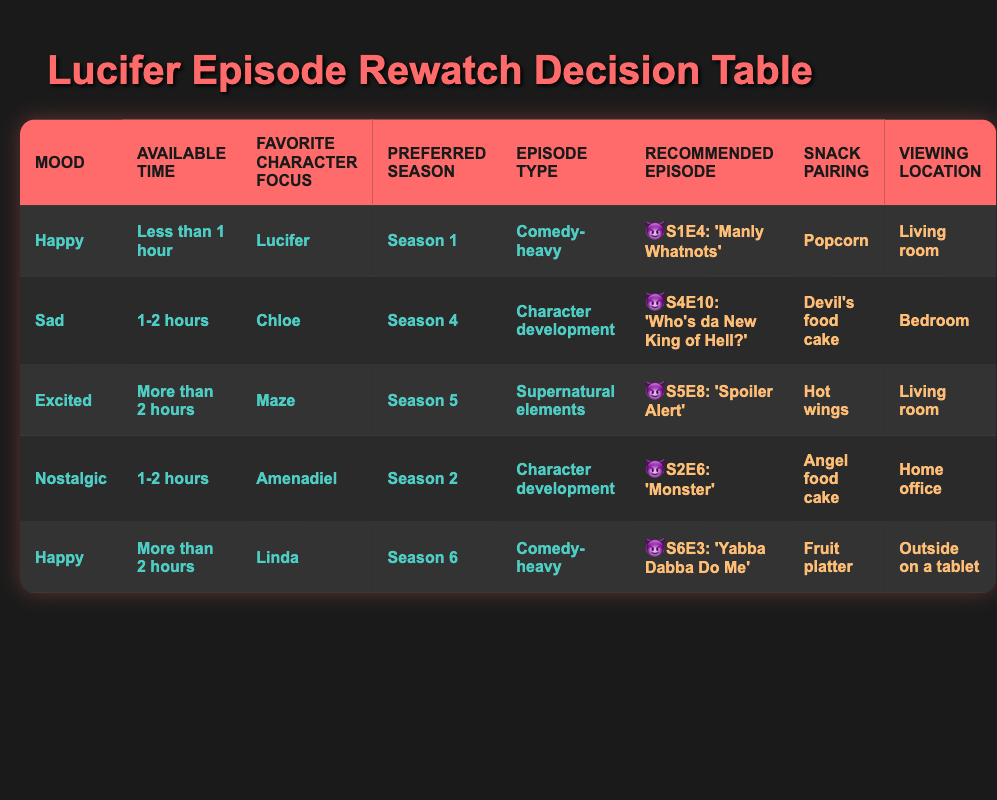What episode is recommended if I'm feeling nostalgic? According to the table, the recommended episode for a nostalgic mood is found in the row where the mood is "Nostalgic." That episode is "S2E6: 'Monster'."
Answer: S2E6: 'Monster' What snack should I pair with watching "S5E8: 'Spoiler Alert'"? In the row that lists "S5E8: 'Spoiler Alert'", the snack pairing is listed as "Hot wings."
Answer: Hot wings Is there a recommended episode for a happy mood with less than 1 hour of available time? Yes, when the mood is "Happy" and available time is "Less than 1 hour," the table suggests the episode "S1E4: 'Manly Whatnots'."
Answer: Yes How many episodes in the table are there for character development? Looking through the table, the following episodes are categorized under "Character development": "S4E10: 'Who's da New King of Hell?'", "S2E6: 'Monster'", and "S5E8: 'Spoiler Alert'." There are 3 episodes that fit this category.
Answer: 2 Which viewing location is suggested for watching a happy episode from Season 6? The row that describes a happy mood with more than 2 hours of available time suggests "Outside on a tablet" as the viewing location for "S6E3: 'Yabba Dabba Do Me'."
Answer: Outside on a tablet If I want to rewatch a case-focused episode, what is my option? By scanning through the episodes, none of the recommended episodes in the table are categorized under "Case-focused." Thus, there is no option available.
Answer: No option available What is the episode with the focus on Amenadiel during the 1-2 hours time slot? The table shows that the episode focusing on Amenadiel with a time availability of 1-2 hours is "S2E6: 'Monster'."
Answer: S2E6: 'Monster' Do any recommendations involve popcorn as a snack? Yes, the table indicates that "S1E4: 'Manly Whatnots'" is paired with popcorn, which correlates with the mood of being happy and having less than an hour.
Answer: Yes What season is "S4E10: 'Who's da New King of Hell?'" from? Referring to the row where this episode is recommended, it is indicated to be from Season 4.
Answer: Season 4 